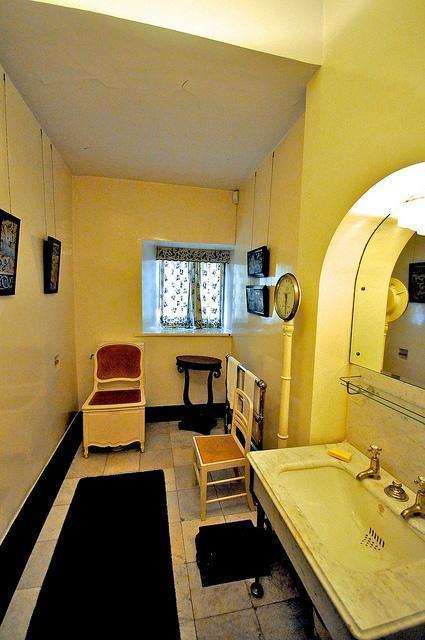How many chairs are in the picture?
Give a very brief answer. 2. How many people have aprons and hats on?
Give a very brief answer. 0. 